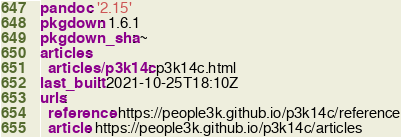<code> <loc_0><loc_0><loc_500><loc_500><_YAML_>pandoc: '2.15'
pkgdown: 1.6.1
pkgdown_sha: ~
articles:
  articles/p3k14c: p3k14c.html
last_built: 2021-10-25T18:10Z
urls:
  reference: https://people3k.github.io/p3k14c/reference
  article: https://people3k.github.io/p3k14c/articles

</code> 